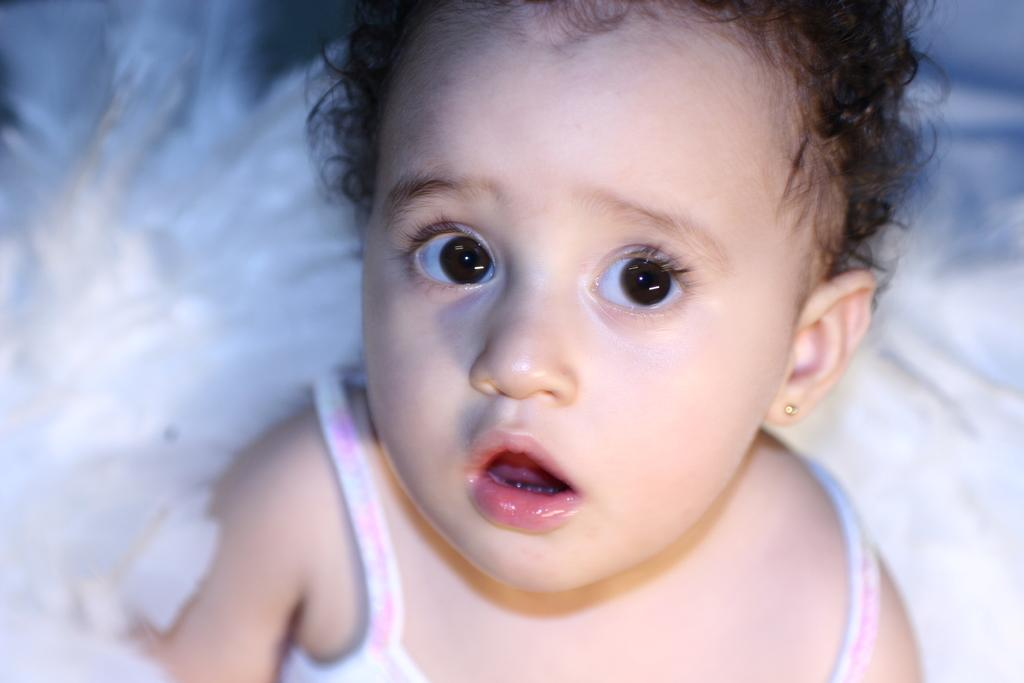What is the main subject of the image? There is a baby in the image. What can be seen in the background of the image? The background of the image is white. What type of sponge is being used by the baby in the image? There is no sponge present in the image. What school-related activity is the baby participating in the image? There is no school-related activity depicted in the image. 